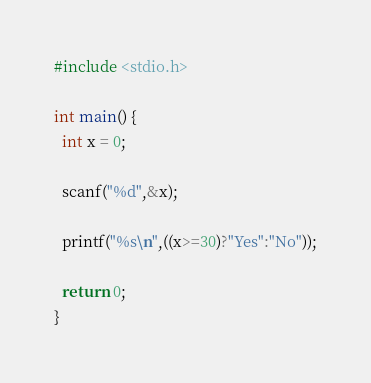Convert code to text. <code><loc_0><loc_0><loc_500><loc_500><_C_>#include <stdio.h>

int main() {
  int x = 0;

  scanf("%d",&x);

  printf("%s\n",((x>=30)?"Yes":"No"));

  return 0;
}</code> 